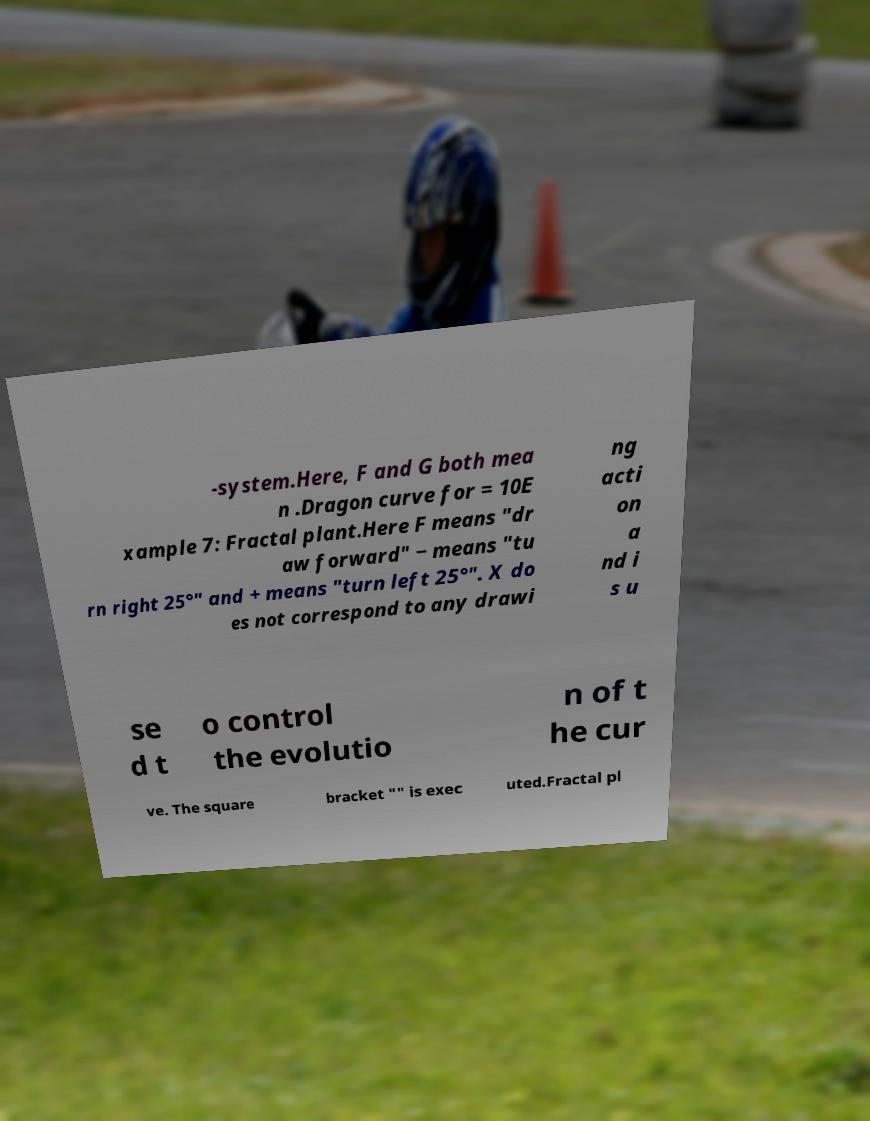Please read and relay the text visible in this image. What does it say? -system.Here, F and G both mea n .Dragon curve for = 10E xample 7: Fractal plant.Here F means "dr aw forward" − means "tu rn right 25°" and + means "turn left 25°". X do es not correspond to any drawi ng acti on a nd i s u se d t o control the evolutio n of t he cur ve. The square bracket "" is exec uted.Fractal pl 